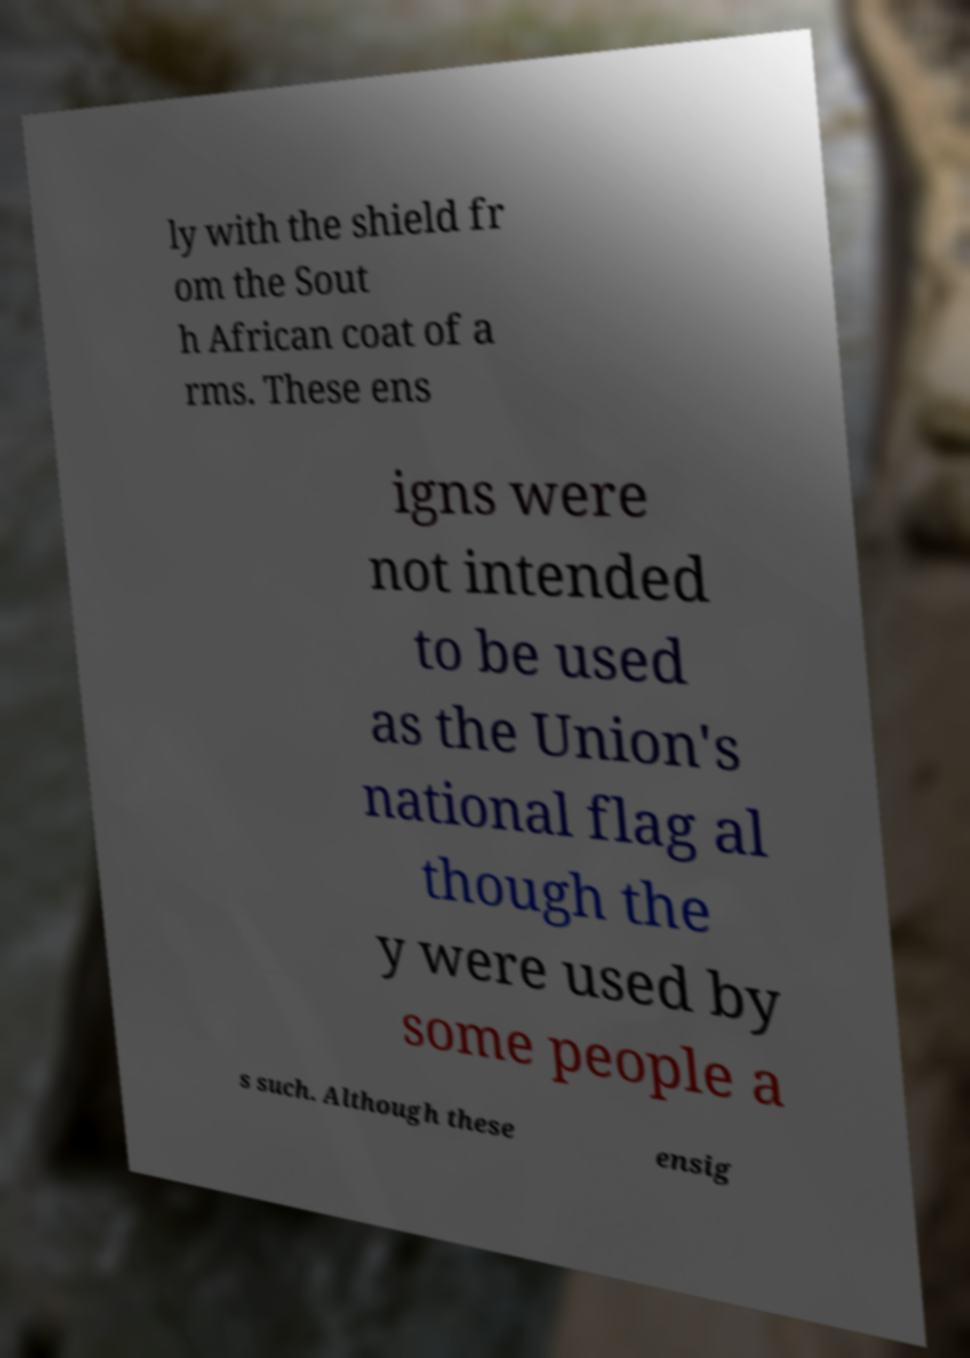Please read and relay the text visible in this image. What does it say? ly with the shield fr om the Sout h African coat of a rms. These ens igns were not intended to be used as the Union's national flag al though the y were used by some people a s such. Although these ensig 